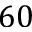<formula> <loc_0><loc_0><loc_500><loc_500>6 0</formula> 